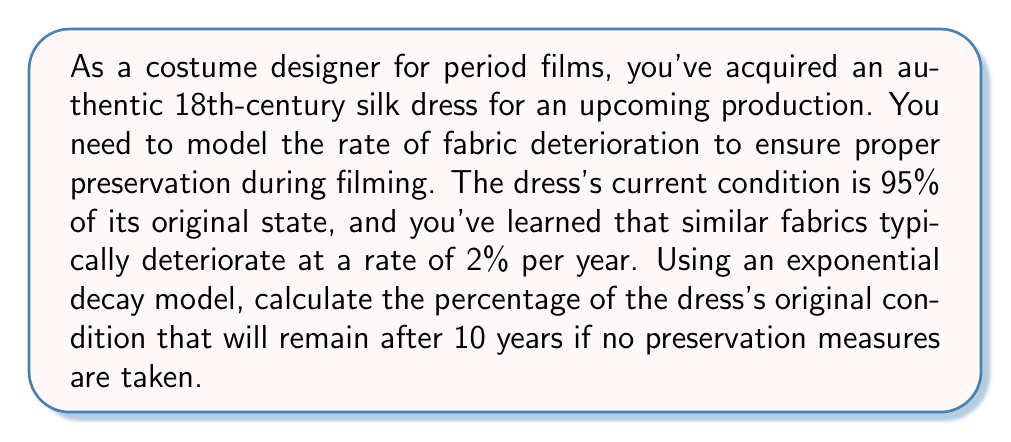Give your solution to this math problem. To solve this problem, we'll use the exponential decay model:

$$A(t) = A_0 e^{-kt}$$

Where:
$A(t)$ is the amount remaining after time $t$
$A_0$ is the initial amount
$k$ is the decay constant
$t$ is the time

1) First, we need to find the decay constant $k$. We're given that the decay rate is 2% per year, which means 98% remains after one year. We can use this information to set up an equation:

   $$0.98 = e^{-k(1)}$$

2) Taking the natural log of both sides:

   $$\ln(0.98) = -k$$

3) Solving for $k$:

   $$k = -\ln(0.98) \approx 0.0202$$

4) Now that we have $k$, we can use the exponential decay formula to find the percentage remaining after 10 years. Our initial amount $A_0$ is 95% (0.95), and $t$ is 10 years:

   $$A(10) = 0.95 e^{-0.0202(10)}$$

5) Calculating this:

   $$A(10) = 0.95 e^{-0.202} \approx 0.7758$$

6) To convert to a percentage, multiply by 100:

   $$0.7758 * 100 \approx 77.58\%$$
Answer: After 10 years, approximately 77.58% of the dress's original condition will remain if no preservation measures are taken. 